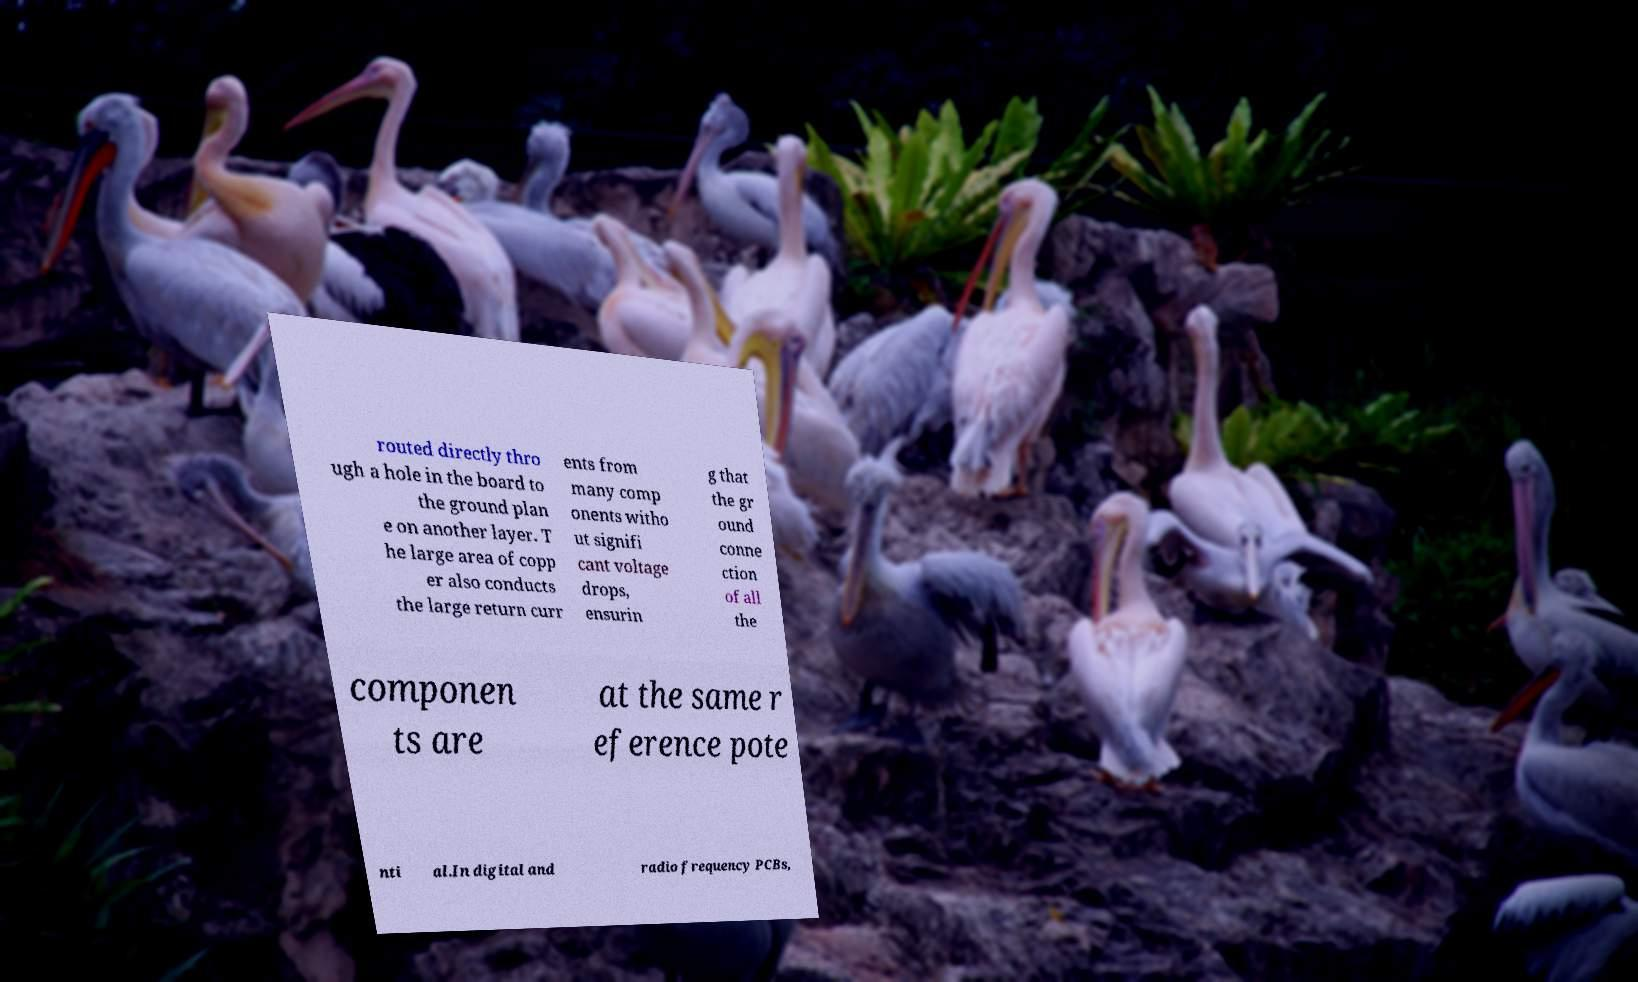I need the written content from this picture converted into text. Can you do that? routed directly thro ugh a hole in the board to the ground plan e on another layer. T he large area of copp er also conducts the large return curr ents from many comp onents witho ut signifi cant voltage drops, ensurin g that the gr ound conne ction of all the componen ts are at the same r eference pote nti al.In digital and radio frequency PCBs, 